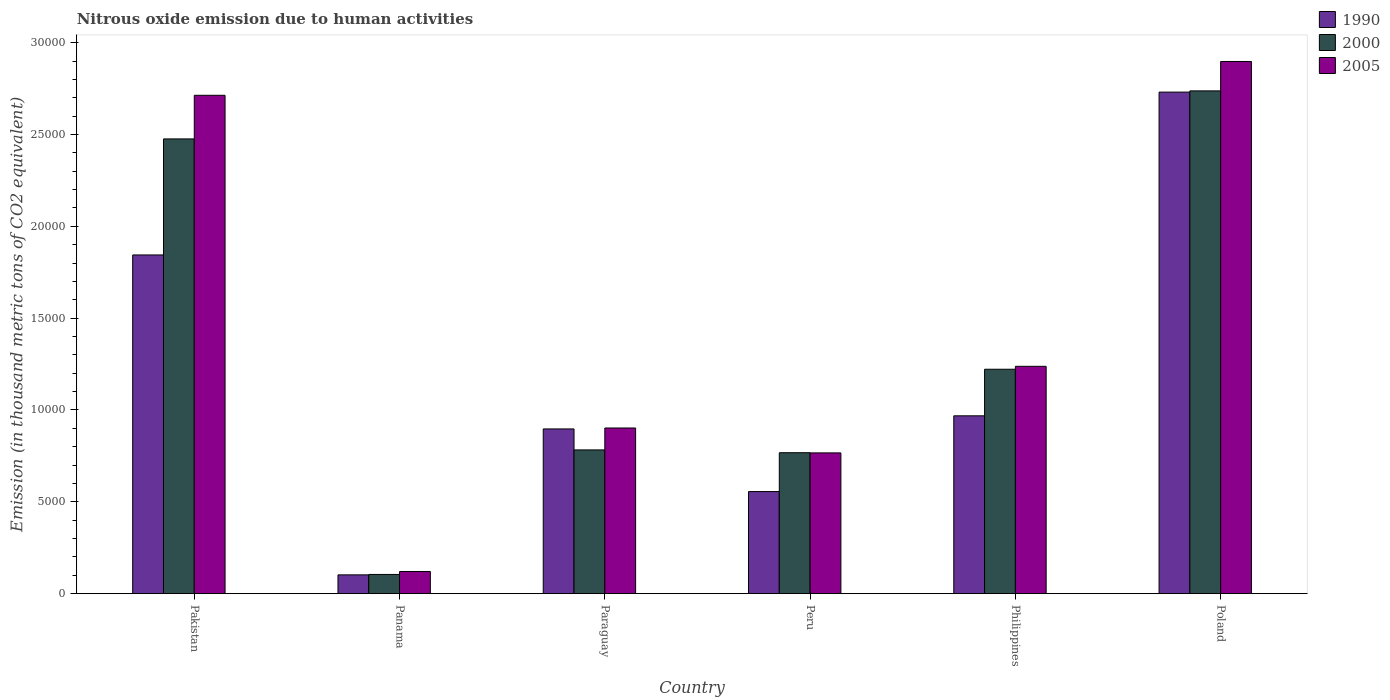How many different coloured bars are there?
Keep it short and to the point. 3. How many groups of bars are there?
Provide a short and direct response. 6. Are the number of bars per tick equal to the number of legend labels?
Your answer should be very brief. Yes. How many bars are there on the 1st tick from the right?
Your answer should be compact. 3. What is the amount of nitrous oxide emitted in 2000 in Paraguay?
Provide a succinct answer. 7826.3. Across all countries, what is the maximum amount of nitrous oxide emitted in 1990?
Ensure brevity in your answer.  2.73e+04. Across all countries, what is the minimum amount of nitrous oxide emitted in 2000?
Your response must be concise. 1046.4. In which country was the amount of nitrous oxide emitted in 2000 maximum?
Offer a very short reply. Poland. In which country was the amount of nitrous oxide emitted in 2000 minimum?
Give a very brief answer. Panama. What is the total amount of nitrous oxide emitted in 2005 in the graph?
Provide a succinct answer. 8.64e+04. What is the difference between the amount of nitrous oxide emitted in 1990 in Philippines and that in Poland?
Provide a succinct answer. -1.76e+04. What is the difference between the amount of nitrous oxide emitted in 1990 in Pakistan and the amount of nitrous oxide emitted in 2000 in Peru?
Offer a terse response. 1.08e+04. What is the average amount of nitrous oxide emitted in 2005 per country?
Provide a succinct answer. 1.44e+04. What is the difference between the amount of nitrous oxide emitted of/in 1990 and amount of nitrous oxide emitted of/in 2005 in Peru?
Provide a short and direct response. -2104.9. What is the ratio of the amount of nitrous oxide emitted in 2005 in Paraguay to that in Philippines?
Provide a succinct answer. 0.73. Is the amount of nitrous oxide emitted in 2000 in Paraguay less than that in Poland?
Your answer should be compact. Yes. Is the difference between the amount of nitrous oxide emitted in 1990 in Pakistan and Poland greater than the difference between the amount of nitrous oxide emitted in 2005 in Pakistan and Poland?
Provide a succinct answer. No. What is the difference between the highest and the second highest amount of nitrous oxide emitted in 2005?
Ensure brevity in your answer.  -1.48e+04. What is the difference between the highest and the lowest amount of nitrous oxide emitted in 1990?
Give a very brief answer. 2.63e+04. Is the sum of the amount of nitrous oxide emitted in 2000 in Peru and Philippines greater than the maximum amount of nitrous oxide emitted in 1990 across all countries?
Give a very brief answer. No. What does the 2nd bar from the left in Poland represents?
Make the answer very short. 2000. Are all the bars in the graph horizontal?
Your answer should be compact. No. Where does the legend appear in the graph?
Make the answer very short. Top right. How many legend labels are there?
Provide a succinct answer. 3. What is the title of the graph?
Keep it short and to the point. Nitrous oxide emission due to human activities. What is the label or title of the X-axis?
Offer a very short reply. Country. What is the label or title of the Y-axis?
Your response must be concise. Emission (in thousand metric tons of CO2 equivalent). What is the Emission (in thousand metric tons of CO2 equivalent) of 1990 in Pakistan?
Your answer should be very brief. 1.84e+04. What is the Emission (in thousand metric tons of CO2 equivalent) of 2000 in Pakistan?
Offer a very short reply. 2.48e+04. What is the Emission (in thousand metric tons of CO2 equivalent) of 2005 in Pakistan?
Make the answer very short. 2.71e+04. What is the Emission (in thousand metric tons of CO2 equivalent) of 1990 in Panama?
Provide a succinct answer. 1023.3. What is the Emission (in thousand metric tons of CO2 equivalent) in 2000 in Panama?
Make the answer very short. 1046.4. What is the Emission (in thousand metric tons of CO2 equivalent) in 2005 in Panama?
Provide a succinct answer. 1207.1. What is the Emission (in thousand metric tons of CO2 equivalent) of 1990 in Paraguay?
Keep it short and to the point. 8968.7. What is the Emission (in thousand metric tons of CO2 equivalent) of 2000 in Paraguay?
Provide a short and direct response. 7826.3. What is the Emission (in thousand metric tons of CO2 equivalent) in 2005 in Paraguay?
Give a very brief answer. 9019.7. What is the Emission (in thousand metric tons of CO2 equivalent) of 1990 in Peru?
Make the answer very short. 5559.3. What is the Emission (in thousand metric tons of CO2 equivalent) in 2000 in Peru?
Your response must be concise. 7673.9. What is the Emission (in thousand metric tons of CO2 equivalent) in 2005 in Peru?
Provide a short and direct response. 7664.2. What is the Emission (in thousand metric tons of CO2 equivalent) in 1990 in Philippines?
Provide a short and direct response. 9682.8. What is the Emission (in thousand metric tons of CO2 equivalent) of 2000 in Philippines?
Provide a succinct answer. 1.22e+04. What is the Emission (in thousand metric tons of CO2 equivalent) in 2005 in Philippines?
Keep it short and to the point. 1.24e+04. What is the Emission (in thousand metric tons of CO2 equivalent) of 1990 in Poland?
Your response must be concise. 2.73e+04. What is the Emission (in thousand metric tons of CO2 equivalent) of 2000 in Poland?
Offer a very short reply. 2.74e+04. What is the Emission (in thousand metric tons of CO2 equivalent) of 2005 in Poland?
Provide a short and direct response. 2.90e+04. Across all countries, what is the maximum Emission (in thousand metric tons of CO2 equivalent) of 1990?
Provide a succinct answer. 2.73e+04. Across all countries, what is the maximum Emission (in thousand metric tons of CO2 equivalent) of 2000?
Keep it short and to the point. 2.74e+04. Across all countries, what is the maximum Emission (in thousand metric tons of CO2 equivalent) of 2005?
Your response must be concise. 2.90e+04. Across all countries, what is the minimum Emission (in thousand metric tons of CO2 equivalent) of 1990?
Keep it short and to the point. 1023.3. Across all countries, what is the minimum Emission (in thousand metric tons of CO2 equivalent) in 2000?
Provide a short and direct response. 1046.4. Across all countries, what is the minimum Emission (in thousand metric tons of CO2 equivalent) of 2005?
Ensure brevity in your answer.  1207.1. What is the total Emission (in thousand metric tons of CO2 equivalent) of 1990 in the graph?
Ensure brevity in your answer.  7.10e+04. What is the total Emission (in thousand metric tons of CO2 equivalent) in 2000 in the graph?
Provide a succinct answer. 8.09e+04. What is the total Emission (in thousand metric tons of CO2 equivalent) in 2005 in the graph?
Give a very brief answer. 8.64e+04. What is the difference between the Emission (in thousand metric tons of CO2 equivalent) of 1990 in Pakistan and that in Panama?
Your response must be concise. 1.74e+04. What is the difference between the Emission (in thousand metric tons of CO2 equivalent) of 2000 in Pakistan and that in Panama?
Make the answer very short. 2.37e+04. What is the difference between the Emission (in thousand metric tons of CO2 equivalent) in 2005 in Pakistan and that in Panama?
Your answer should be compact. 2.59e+04. What is the difference between the Emission (in thousand metric tons of CO2 equivalent) of 1990 in Pakistan and that in Paraguay?
Provide a short and direct response. 9473. What is the difference between the Emission (in thousand metric tons of CO2 equivalent) of 2000 in Pakistan and that in Paraguay?
Offer a very short reply. 1.69e+04. What is the difference between the Emission (in thousand metric tons of CO2 equivalent) in 2005 in Pakistan and that in Paraguay?
Your answer should be compact. 1.81e+04. What is the difference between the Emission (in thousand metric tons of CO2 equivalent) of 1990 in Pakistan and that in Peru?
Provide a short and direct response. 1.29e+04. What is the difference between the Emission (in thousand metric tons of CO2 equivalent) of 2000 in Pakistan and that in Peru?
Provide a succinct answer. 1.71e+04. What is the difference between the Emission (in thousand metric tons of CO2 equivalent) in 2005 in Pakistan and that in Peru?
Your answer should be compact. 1.95e+04. What is the difference between the Emission (in thousand metric tons of CO2 equivalent) of 1990 in Pakistan and that in Philippines?
Make the answer very short. 8758.9. What is the difference between the Emission (in thousand metric tons of CO2 equivalent) in 2000 in Pakistan and that in Philippines?
Make the answer very short. 1.25e+04. What is the difference between the Emission (in thousand metric tons of CO2 equivalent) in 2005 in Pakistan and that in Philippines?
Keep it short and to the point. 1.48e+04. What is the difference between the Emission (in thousand metric tons of CO2 equivalent) in 1990 in Pakistan and that in Poland?
Provide a short and direct response. -8866.4. What is the difference between the Emission (in thousand metric tons of CO2 equivalent) of 2000 in Pakistan and that in Poland?
Your answer should be compact. -2615.2. What is the difference between the Emission (in thousand metric tons of CO2 equivalent) of 2005 in Pakistan and that in Poland?
Offer a terse response. -1841. What is the difference between the Emission (in thousand metric tons of CO2 equivalent) of 1990 in Panama and that in Paraguay?
Give a very brief answer. -7945.4. What is the difference between the Emission (in thousand metric tons of CO2 equivalent) in 2000 in Panama and that in Paraguay?
Offer a terse response. -6779.9. What is the difference between the Emission (in thousand metric tons of CO2 equivalent) of 2005 in Panama and that in Paraguay?
Your answer should be very brief. -7812.6. What is the difference between the Emission (in thousand metric tons of CO2 equivalent) of 1990 in Panama and that in Peru?
Make the answer very short. -4536. What is the difference between the Emission (in thousand metric tons of CO2 equivalent) in 2000 in Panama and that in Peru?
Give a very brief answer. -6627.5. What is the difference between the Emission (in thousand metric tons of CO2 equivalent) in 2005 in Panama and that in Peru?
Make the answer very short. -6457.1. What is the difference between the Emission (in thousand metric tons of CO2 equivalent) of 1990 in Panama and that in Philippines?
Give a very brief answer. -8659.5. What is the difference between the Emission (in thousand metric tons of CO2 equivalent) of 2000 in Panama and that in Philippines?
Ensure brevity in your answer.  -1.12e+04. What is the difference between the Emission (in thousand metric tons of CO2 equivalent) in 2005 in Panama and that in Philippines?
Make the answer very short. -1.12e+04. What is the difference between the Emission (in thousand metric tons of CO2 equivalent) of 1990 in Panama and that in Poland?
Provide a short and direct response. -2.63e+04. What is the difference between the Emission (in thousand metric tons of CO2 equivalent) in 2000 in Panama and that in Poland?
Provide a short and direct response. -2.63e+04. What is the difference between the Emission (in thousand metric tons of CO2 equivalent) in 2005 in Panama and that in Poland?
Your answer should be compact. -2.78e+04. What is the difference between the Emission (in thousand metric tons of CO2 equivalent) of 1990 in Paraguay and that in Peru?
Keep it short and to the point. 3409.4. What is the difference between the Emission (in thousand metric tons of CO2 equivalent) of 2000 in Paraguay and that in Peru?
Your response must be concise. 152.4. What is the difference between the Emission (in thousand metric tons of CO2 equivalent) in 2005 in Paraguay and that in Peru?
Your answer should be compact. 1355.5. What is the difference between the Emission (in thousand metric tons of CO2 equivalent) of 1990 in Paraguay and that in Philippines?
Make the answer very short. -714.1. What is the difference between the Emission (in thousand metric tons of CO2 equivalent) in 2000 in Paraguay and that in Philippines?
Your answer should be very brief. -4392.8. What is the difference between the Emission (in thousand metric tons of CO2 equivalent) of 2005 in Paraguay and that in Philippines?
Provide a succinct answer. -3358.4. What is the difference between the Emission (in thousand metric tons of CO2 equivalent) in 1990 in Paraguay and that in Poland?
Provide a short and direct response. -1.83e+04. What is the difference between the Emission (in thousand metric tons of CO2 equivalent) in 2000 in Paraguay and that in Poland?
Offer a terse response. -1.95e+04. What is the difference between the Emission (in thousand metric tons of CO2 equivalent) of 2005 in Paraguay and that in Poland?
Offer a terse response. -2.00e+04. What is the difference between the Emission (in thousand metric tons of CO2 equivalent) of 1990 in Peru and that in Philippines?
Make the answer very short. -4123.5. What is the difference between the Emission (in thousand metric tons of CO2 equivalent) in 2000 in Peru and that in Philippines?
Provide a succinct answer. -4545.2. What is the difference between the Emission (in thousand metric tons of CO2 equivalent) of 2005 in Peru and that in Philippines?
Provide a succinct answer. -4713.9. What is the difference between the Emission (in thousand metric tons of CO2 equivalent) in 1990 in Peru and that in Poland?
Offer a terse response. -2.17e+04. What is the difference between the Emission (in thousand metric tons of CO2 equivalent) of 2000 in Peru and that in Poland?
Provide a succinct answer. -1.97e+04. What is the difference between the Emission (in thousand metric tons of CO2 equivalent) of 2005 in Peru and that in Poland?
Your answer should be compact. -2.13e+04. What is the difference between the Emission (in thousand metric tons of CO2 equivalent) of 1990 in Philippines and that in Poland?
Ensure brevity in your answer.  -1.76e+04. What is the difference between the Emission (in thousand metric tons of CO2 equivalent) in 2000 in Philippines and that in Poland?
Your answer should be compact. -1.52e+04. What is the difference between the Emission (in thousand metric tons of CO2 equivalent) in 2005 in Philippines and that in Poland?
Give a very brief answer. -1.66e+04. What is the difference between the Emission (in thousand metric tons of CO2 equivalent) in 1990 in Pakistan and the Emission (in thousand metric tons of CO2 equivalent) in 2000 in Panama?
Provide a succinct answer. 1.74e+04. What is the difference between the Emission (in thousand metric tons of CO2 equivalent) of 1990 in Pakistan and the Emission (in thousand metric tons of CO2 equivalent) of 2005 in Panama?
Your response must be concise. 1.72e+04. What is the difference between the Emission (in thousand metric tons of CO2 equivalent) in 2000 in Pakistan and the Emission (in thousand metric tons of CO2 equivalent) in 2005 in Panama?
Your answer should be compact. 2.36e+04. What is the difference between the Emission (in thousand metric tons of CO2 equivalent) in 1990 in Pakistan and the Emission (in thousand metric tons of CO2 equivalent) in 2000 in Paraguay?
Your response must be concise. 1.06e+04. What is the difference between the Emission (in thousand metric tons of CO2 equivalent) in 1990 in Pakistan and the Emission (in thousand metric tons of CO2 equivalent) in 2005 in Paraguay?
Your answer should be compact. 9422. What is the difference between the Emission (in thousand metric tons of CO2 equivalent) of 2000 in Pakistan and the Emission (in thousand metric tons of CO2 equivalent) of 2005 in Paraguay?
Make the answer very short. 1.57e+04. What is the difference between the Emission (in thousand metric tons of CO2 equivalent) of 1990 in Pakistan and the Emission (in thousand metric tons of CO2 equivalent) of 2000 in Peru?
Ensure brevity in your answer.  1.08e+04. What is the difference between the Emission (in thousand metric tons of CO2 equivalent) of 1990 in Pakistan and the Emission (in thousand metric tons of CO2 equivalent) of 2005 in Peru?
Give a very brief answer. 1.08e+04. What is the difference between the Emission (in thousand metric tons of CO2 equivalent) in 2000 in Pakistan and the Emission (in thousand metric tons of CO2 equivalent) in 2005 in Peru?
Your response must be concise. 1.71e+04. What is the difference between the Emission (in thousand metric tons of CO2 equivalent) in 1990 in Pakistan and the Emission (in thousand metric tons of CO2 equivalent) in 2000 in Philippines?
Provide a succinct answer. 6222.6. What is the difference between the Emission (in thousand metric tons of CO2 equivalent) of 1990 in Pakistan and the Emission (in thousand metric tons of CO2 equivalent) of 2005 in Philippines?
Your answer should be very brief. 6063.6. What is the difference between the Emission (in thousand metric tons of CO2 equivalent) in 2000 in Pakistan and the Emission (in thousand metric tons of CO2 equivalent) in 2005 in Philippines?
Ensure brevity in your answer.  1.24e+04. What is the difference between the Emission (in thousand metric tons of CO2 equivalent) of 1990 in Pakistan and the Emission (in thousand metric tons of CO2 equivalent) of 2000 in Poland?
Offer a terse response. -8933.2. What is the difference between the Emission (in thousand metric tons of CO2 equivalent) in 1990 in Pakistan and the Emission (in thousand metric tons of CO2 equivalent) in 2005 in Poland?
Give a very brief answer. -1.05e+04. What is the difference between the Emission (in thousand metric tons of CO2 equivalent) in 2000 in Pakistan and the Emission (in thousand metric tons of CO2 equivalent) in 2005 in Poland?
Make the answer very short. -4215.8. What is the difference between the Emission (in thousand metric tons of CO2 equivalent) in 1990 in Panama and the Emission (in thousand metric tons of CO2 equivalent) in 2000 in Paraguay?
Make the answer very short. -6803. What is the difference between the Emission (in thousand metric tons of CO2 equivalent) of 1990 in Panama and the Emission (in thousand metric tons of CO2 equivalent) of 2005 in Paraguay?
Offer a very short reply. -7996.4. What is the difference between the Emission (in thousand metric tons of CO2 equivalent) of 2000 in Panama and the Emission (in thousand metric tons of CO2 equivalent) of 2005 in Paraguay?
Your answer should be very brief. -7973.3. What is the difference between the Emission (in thousand metric tons of CO2 equivalent) in 1990 in Panama and the Emission (in thousand metric tons of CO2 equivalent) in 2000 in Peru?
Offer a terse response. -6650.6. What is the difference between the Emission (in thousand metric tons of CO2 equivalent) in 1990 in Panama and the Emission (in thousand metric tons of CO2 equivalent) in 2005 in Peru?
Your answer should be compact. -6640.9. What is the difference between the Emission (in thousand metric tons of CO2 equivalent) of 2000 in Panama and the Emission (in thousand metric tons of CO2 equivalent) of 2005 in Peru?
Provide a succinct answer. -6617.8. What is the difference between the Emission (in thousand metric tons of CO2 equivalent) in 1990 in Panama and the Emission (in thousand metric tons of CO2 equivalent) in 2000 in Philippines?
Give a very brief answer. -1.12e+04. What is the difference between the Emission (in thousand metric tons of CO2 equivalent) of 1990 in Panama and the Emission (in thousand metric tons of CO2 equivalent) of 2005 in Philippines?
Your response must be concise. -1.14e+04. What is the difference between the Emission (in thousand metric tons of CO2 equivalent) in 2000 in Panama and the Emission (in thousand metric tons of CO2 equivalent) in 2005 in Philippines?
Your answer should be compact. -1.13e+04. What is the difference between the Emission (in thousand metric tons of CO2 equivalent) in 1990 in Panama and the Emission (in thousand metric tons of CO2 equivalent) in 2000 in Poland?
Provide a short and direct response. -2.64e+04. What is the difference between the Emission (in thousand metric tons of CO2 equivalent) of 1990 in Panama and the Emission (in thousand metric tons of CO2 equivalent) of 2005 in Poland?
Provide a succinct answer. -2.80e+04. What is the difference between the Emission (in thousand metric tons of CO2 equivalent) of 2000 in Panama and the Emission (in thousand metric tons of CO2 equivalent) of 2005 in Poland?
Provide a short and direct response. -2.79e+04. What is the difference between the Emission (in thousand metric tons of CO2 equivalent) of 1990 in Paraguay and the Emission (in thousand metric tons of CO2 equivalent) of 2000 in Peru?
Offer a very short reply. 1294.8. What is the difference between the Emission (in thousand metric tons of CO2 equivalent) of 1990 in Paraguay and the Emission (in thousand metric tons of CO2 equivalent) of 2005 in Peru?
Provide a succinct answer. 1304.5. What is the difference between the Emission (in thousand metric tons of CO2 equivalent) of 2000 in Paraguay and the Emission (in thousand metric tons of CO2 equivalent) of 2005 in Peru?
Your answer should be very brief. 162.1. What is the difference between the Emission (in thousand metric tons of CO2 equivalent) of 1990 in Paraguay and the Emission (in thousand metric tons of CO2 equivalent) of 2000 in Philippines?
Offer a very short reply. -3250.4. What is the difference between the Emission (in thousand metric tons of CO2 equivalent) in 1990 in Paraguay and the Emission (in thousand metric tons of CO2 equivalent) in 2005 in Philippines?
Give a very brief answer. -3409.4. What is the difference between the Emission (in thousand metric tons of CO2 equivalent) in 2000 in Paraguay and the Emission (in thousand metric tons of CO2 equivalent) in 2005 in Philippines?
Your response must be concise. -4551.8. What is the difference between the Emission (in thousand metric tons of CO2 equivalent) of 1990 in Paraguay and the Emission (in thousand metric tons of CO2 equivalent) of 2000 in Poland?
Keep it short and to the point. -1.84e+04. What is the difference between the Emission (in thousand metric tons of CO2 equivalent) of 1990 in Paraguay and the Emission (in thousand metric tons of CO2 equivalent) of 2005 in Poland?
Give a very brief answer. -2.00e+04. What is the difference between the Emission (in thousand metric tons of CO2 equivalent) in 2000 in Paraguay and the Emission (in thousand metric tons of CO2 equivalent) in 2005 in Poland?
Keep it short and to the point. -2.11e+04. What is the difference between the Emission (in thousand metric tons of CO2 equivalent) of 1990 in Peru and the Emission (in thousand metric tons of CO2 equivalent) of 2000 in Philippines?
Ensure brevity in your answer.  -6659.8. What is the difference between the Emission (in thousand metric tons of CO2 equivalent) of 1990 in Peru and the Emission (in thousand metric tons of CO2 equivalent) of 2005 in Philippines?
Make the answer very short. -6818.8. What is the difference between the Emission (in thousand metric tons of CO2 equivalent) in 2000 in Peru and the Emission (in thousand metric tons of CO2 equivalent) in 2005 in Philippines?
Offer a terse response. -4704.2. What is the difference between the Emission (in thousand metric tons of CO2 equivalent) of 1990 in Peru and the Emission (in thousand metric tons of CO2 equivalent) of 2000 in Poland?
Provide a succinct answer. -2.18e+04. What is the difference between the Emission (in thousand metric tons of CO2 equivalent) of 1990 in Peru and the Emission (in thousand metric tons of CO2 equivalent) of 2005 in Poland?
Offer a very short reply. -2.34e+04. What is the difference between the Emission (in thousand metric tons of CO2 equivalent) in 2000 in Peru and the Emission (in thousand metric tons of CO2 equivalent) in 2005 in Poland?
Offer a very short reply. -2.13e+04. What is the difference between the Emission (in thousand metric tons of CO2 equivalent) of 1990 in Philippines and the Emission (in thousand metric tons of CO2 equivalent) of 2000 in Poland?
Your answer should be very brief. -1.77e+04. What is the difference between the Emission (in thousand metric tons of CO2 equivalent) of 1990 in Philippines and the Emission (in thousand metric tons of CO2 equivalent) of 2005 in Poland?
Make the answer very short. -1.93e+04. What is the difference between the Emission (in thousand metric tons of CO2 equivalent) in 2000 in Philippines and the Emission (in thousand metric tons of CO2 equivalent) in 2005 in Poland?
Offer a terse response. -1.68e+04. What is the average Emission (in thousand metric tons of CO2 equivalent) of 1990 per country?
Ensure brevity in your answer.  1.18e+04. What is the average Emission (in thousand metric tons of CO2 equivalent) of 2000 per country?
Your response must be concise. 1.35e+04. What is the average Emission (in thousand metric tons of CO2 equivalent) of 2005 per country?
Provide a succinct answer. 1.44e+04. What is the difference between the Emission (in thousand metric tons of CO2 equivalent) of 1990 and Emission (in thousand metric tons of CO2 equivalent) of 2000 in Pakistan?
Your response must be concise. -6318. What is the difference between the Emission (in thousand metric tons of CO2 equivalent) of 1990 and Emission (in thousand metric tons of CO2 equivalent) of 2005 in Pakistan?
Provide a succinct answer. -8692.8. What is the difference between the Emission (in thousand metric tons of CO2 equivalent) in 2000 and Emission (in thousand metric tons of CO2 equivalent) in 2005 in Pakistan?
Offer a very short reply. -2374.8. What is the difference between the Emission (in thousand metric tons of CO2 equivalent) in 1990 and Emission (in thousand metric tons of CO2 equivalent) in 2000 in Panama?
Keep it short and to the point. -23.1. What is the difference between the Emission (in thousand metric tons of CO2 equivalent) of 1990 and Emission (in thousand metric tons of CO2 equivalent) of 2005 in Panama?
Make the answer very short. -183.8. What is the difference between the Emission (in thousand metric tons of CO2 equivalent) in 2000 and Emission (in thousand metric tons of CO2 equivalent) in 2005 in Panama?
Offer a very short reply. -160.7. What is the difference between the Emission (in thousand metric tons of CO2 equivalent) in 1990 and Emission (in thousand metric tons of CO2 equivalent) in 2000 in Paraguay?
Provide a short and direct response. 1142.4. What is the difference between the Emission (in thousand metric tons of CO2 equivalent) of 1990 and Emission (in thousand metric tons of CO2 equivalent) of 2005 in Paraguay?
Provide a short and direct response. -51. What is the difference between the Emission (in thousand metric tons of CO2 equivalent) of 2000 and Emission (in thousand metric tons of CO2 equivalent) of 2005 in Paraguay?
Your response must be concise. -1193.4. What is the difference between the Emission (in thousand metric tons of CO2 equivalent) of 1990 and Emission (in thousand metric tons of CO2 equivalent) of 2000 in Peru?
Keep it short and to the point. -2114.6. What is the difference between the Emission (in thousand metric tons of CO2 equivalent) of 1990 and Emission (in thousand metric tons of CO2 equivalent) of 2005 in Peru?
Keep it short and to the point. -2104.9. What is the difference between the Emission (in thousand metric tons of CO2 equivalent) of 1990 and Emission (in thousand metric tons of CO2 equivalent) of 2000 in Philippines?
Your answer should be very brief. -2536.3. What is the difference between the Emission (in thousand metric tons of CO2 equivalent) of 1990 and Emission (in thousand metric tons of CO2 equivalent) of 2005 in Philippines?
Make the answer very short. -2695.3. What is the difference between the Emission (in thousand metric tons of CO2 equivalent) of 2000 and Emission (in thousand metric tons of CO2 equivalent) of 2005 in Philippines?
Give a very brief answer. -159. What is the difference between the Emission (in thousand metric tons of CO2 equivalent) of 1990 and Emission (in thousand metric tons of CO2 equivalent) of 2000 in Poland?
Ensure brevity in your answer.  -66.8. What is the difference between the Emission (in thousand metric tons of CO2 equivalent) in 1990 and Emission (in thousand metric tons of CO2 equivalent) in 2005 in Poland?
Your answer should be very brief. -1667.4. What is the difference between the Emission (in thousand metric tons of CO2 equivalent) in 2000 and Emission (in thousand metric tons of CO2 equivalent) in 2005 in Poland?
Ensure brevity in your answer.  -1600.6. What is the ratio of the Emission (in thousand metric tons of CO2 equivalent) of 1990 in Pakistan to that in Panama?
Provide a succinct answer. 18.02. What is the ratio of the Emission (in thousand metric tons of CO2 equivalent) in 2000 in Pakistan to that in Panama?
Keep it short and to the point. 23.66. What is the ratio of the Emission (in thousand metric tons of CO2 equivalent) in 2005 in Pakistan to that in Panama?
Your response must be concise. 22.48. What is the ratio of the Emission (in thousand metric tons of CO2 equivalent) of 1990 in Pakistan to that in Paraguay?
Ensure brevity in your answer.  2.06. What is the ratio of the Emission (in thousand metric tons of CO2 equivalent) in 2000 in Pakistan to that in Paraguay?
Make the answer very short. 3.16. What is the ratio of the Emission (in thousand metric tons of CO2 equivalent) of 2005 in Pakistan to that in Paraguay?
Make the answer very short. 3.01. What is the ratio of the Emission (in thousand metric tons of CO2 equivalent) in 1990 in Pakistan to that in Peru?
Your answer should be very brief. 3.32. What is the ratio of the Emission (in thousand metric tons of CO2 equivalent) of 2000 in Pakistan to that in Peru?
Keep it short and to the point. 3.23. What is the ratio of the Emission (in thousand metric tons of CO2 equivalent) of 2005 in Pakistan to that in Peru?
Give a very brief answer. 3.54. What is the ratio of the Emission (in thousand metric tons of CO2 equivalent) of 1990 in Pakistan to that in Philippines?
Give a very brief answer. 1.9. What is the ratio of the Emission (in thousand metric tons of CO2 equivalent) of 2000 in Pakistan to that in Philippines?
Offer a very short reply. 2.03. What is the ratio of the Emission (in thousand metric tons of CO2 equivalent) of 2005 in Pakistan to that in Philippines?
Offer a terse response. 2.19. What is the ratio of the Emission (in thousand metric tons of CO2 equivalent) of 1990 in Pakistan to that in Poland?
Your answer should be compact. 0.68. What is the ratio of the Emission (in thousand metric tons of CO2 equivalent) of 2000 in Pakistan to that in Poland?
Your response must be concise. 0.9. What is the ratio of the Emission (in thousand metric tons of CO2 equivalent) in 2005 in Pakistan to that in Poland?
Your answer should be very brief. 0.94. What is the ratio of the Emission (in thousand metric tons of CO2 equivalent) of 1990 in Panama to that in Paraguay?
Your answer should be very brief. 0.11. What is the ratio of the Emission (in thousand metric tons of CO2 equivalent) of 2000 in Panama to that in Paraguay?
Ensure brevity in your answer.  0.13. What is the ratio of the Emission (in thousand metric tons of CO2 equivalent) in 2005 in Panama to that in Paraguay?
Ensure brevity in your answer.  0.13. What is the ratio of the Emission (in thousand metric tons of CO2 equivalent) of 1990 in Panama to that in Peru?
Provide a succinct answer. 0.18. What is the ratio of the Emission (in thousand metric tons of CO2 equivalent) in 2000 in Panama to that in Peru?
Your response must be concise. 0.14. What is the ratio of the Emission (in thousand metric tons of CO2 equivalent) of 2005 in Panama to that in Peru?
Provide a succinct answer. 0.16. What is the ratio of the Emission (in thousand metric tons of CO2 equivalent) in 1990 in Panama to that in Philippines?
Your answer should be very brief. 0.11. What is the ratio of the Emission (in thousand metric tons of CO2 equivalent) in 2000 in Panama to that in Philippines?
Offer a terse response. 0.09. What is the ratio of the Emission (in thousand metric tons of CO2 equivalent) of 2005 in Panama to that in Philippines?
Make the answer very short. 0.1. What is the ratio of the Emission (in thousand metric tons of CO2 equivalent) in 1990 in Panama to that in Poland?
Keep it short and to the point. 0.04. What is the ratio of the Emission (in thousand metric tons of CO2 equivalent) of 2000 in Panama to that in Poland?
Provide a short and direct response. 0.04. What is the ratio of the Emission (in thousand metric tons of CO2 equivalent) of 2005 in Panama to that in Poland?
Ensure brevity in your answer.  0.04. What is the ratio of the Emission (in thousand metric tons of CO2 equivalent) in 1990 in Paraguay to that in Peru?
Your answer should be very brief. 1.61. What is the ratio of the Emission (in thousand metric tons of CO2 equivalent) in 2000 in Paraguay to that in Peru?
Your answer should be compact. 1.02. What is the ratio of the Emission (in thousand metric tons of CO2 equivalent) of 2005 in Paraguay to that in Peru?
Make the answer very short. 1.18. What is the ratio of the Emission (in thousand metric tons of CO2 equivalent) of 1990 in Paraguay to that in Philippines?
Offer a very short reply. 0.93. What is the ratio of the Emission (in thousand metric tons of CO2 equivalent) in 2000 in Paraguay to that in Philippines?
Ensure brevity in your answer.  0.64. What is the ratio of the Emission (in thousand metric tons of CO2 equivalent) of 2005 in Paraguay to that in Philippines?
Provide a succinct answer. 0.73. What is the ratio of the Emission (in thousand metric tons of CO2 equivalent) in 1990 in Paraguay to that in Poland?
Ensure brevity in your answer.  0.33. What is the ratio of the Emission (in thousand metric tons of CO2 equivalent) in 2000 in Paraguay to that in Poland?
Provide a short and direct response. 0.29. What is the ratio of the Emission (in thousand metric tons of CO2 equivalent) of 2005 in Paraguay to that in Poland?
Provide a succinct answer. 0.31. What is the ratio of the Emission (in thousand metric tons of CO2 equivalent) in 1990 in Peru to that in Philippines?
Your response must be concise. 0.57. What is the ratio of the Emission (in thousand metric tons of CO2 equivalent) of 2000 in Peru to that in Philippines?
Keep it short and to the point. 0.63. What is the ratio of the Emission (in thousand metric tons of CO2 equivalent) in 2005 in Peru to that in Philippines?
Ensure brevity in your answer.  0.62. What is the ratio of the Emission (in thousand metric tons of CO2 equivalent) in 1990 in Peru to that in Poland?
Keep it short and to the point. 0.2. What is the ratio of the Emission (in thousand metric tons of CO2 equivalent) in 2000 in Peru to that in Poland?
Provide a short and direct response. 0.28. What is the ratio of the Emission (in thousand metric tons of CO2 equivalent) in 2005 in Peru to that in Poland?
Your answer should be compact. 0.26. What is the ratio of the Emission (in thousand metric tons of CO2 equivalent) in 1990 in Philippines to that in Poland?
Your response must be concise. 0.35. What is the ratio of the Emission (in thousand metric tons of CO2 equivalent) of 2000 in Philippines to that in Poland?
Offer a terse response. 0.45. What is the ratio of the Emission (in thousand metric tons of CO2 equivalent) in 2005 in Philippines to that in Poland?
Provide a succinct answer. 0.43. What is the difference between the highest and the second highest Emission (in thousand metric tons of CO2 equivalent) in 1990?
Give a very brief answer. 8866.4. What is the difference between the highest and the second highest Emission (in thousand metric tons of CO2 equivalent) of 2000?
Your answer should be compact. 2615.2. What is the difference between the highest and the second highest Emission (in thousand metric tons of CO2 equivalent) of 2005?
Keep it short and to the point. 1841. What is the difference between the highest and the lowest Emission (in thousand metric tons of CO2 equivalent) of 1990?
Your answer should be very brief. 2.63e+04. What is the difference between the highest and the lowest Emission (in thousand metric tons of CO2 equivalent) in 2000?
Offer a terse response. 2.63e+04. What is the difference between the highest and the lowest Emission (in thousand metric tons of CO2 equivalent) in 2005?
Your response must be concise. 2.78e+04. 